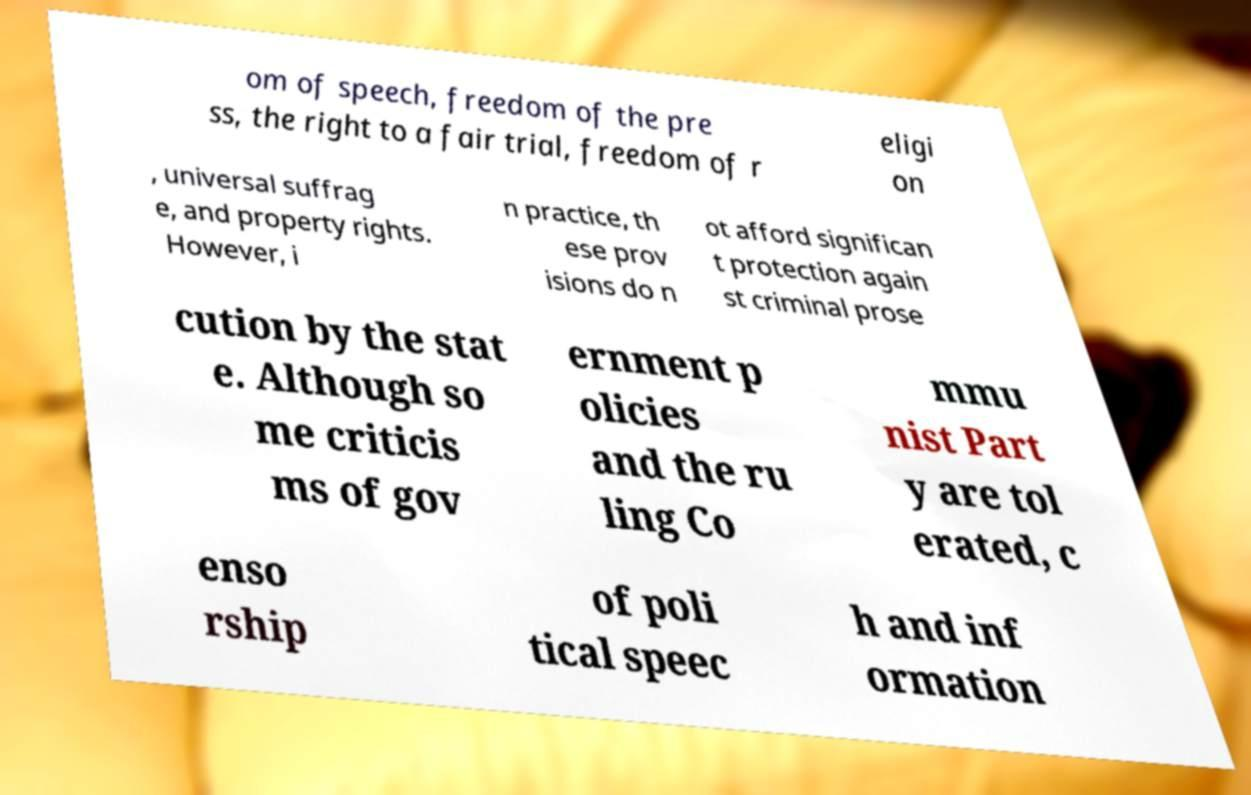Please identify and transcribe the text found in this image. om of speech, freedom of the pre ss, the right to a fair trial, freedom of r eligi on , universal suffrag e, and property rights. However, i n practice, th ese prov isions do n ot afford significan t protection again st criminal prose cution by the stat e. Although so me criticis ms of gov ernment p olicies and the ru ling Co mmu nist Part y are tol erated, c enso rship of poli tical speec h and inf ormation 